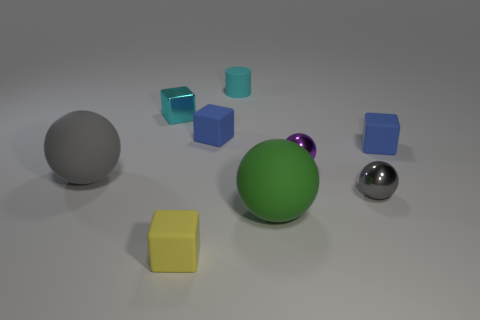What number of matte things are either small purple spheres or yellow things?
Keep it short and to the point. 1. Is there a tiny metal object behind the tiny blue rubber block that is left of the green ball?
Provide a succinct answer. Yes. Do the cyan block that is behind the green matte object and the cylinder have the same material?
Give a very brief answer. No. Does the cylinder have the same color as the metal cube?
Offer a terse response. Yes. What is the size of the rubber block right of the matte sphere on the right side of the tiny cyan matte cylinder?
Make the answer very short. Small. Are the big ball right of the yellow thing and the tiny sphere on the left side of the tiny gray ball made of the same material?
Provide a short and direct response. No. Is the color of the large rubber sphere right of the tiny rubber cylinder the same as the cylinder?
Your response must be concise. No. What number of small yellow matte blocks are left of the tiny rubber cylinder?
Keep it short and to the point. 1. Does the yellow block have the same material as the small cyan thing that is to the left of the small cyan cylinder?
Ensure brevity in your answer.  No. There is a cyan cube that is the same material as the small gray object; what is its size?
Ensure brevity in your answer.  Small. 